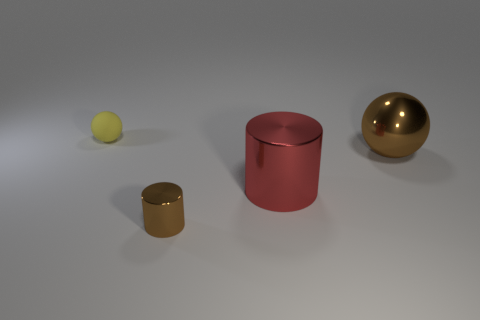What is the shape of the small brown thing?
Your response must be concise. Cylinder. How many other objects are the same material as the tiny brown cylinder?
Keep it short and to the point. 2. Do the red shiny cylinder and the brown sphere have the same size?
Your answer should be very brief. Yes. There is a object left of the brown shiny cylinder; what shape is it?
Your answer should be very brief. Sphere. What is the color of the small thing that is to the right of the ball that is on the left side of the small brown metallic thing?
Give a very brief answer. Brown. Do the metal object in front of the large red thing and the large object in front of the brown metallic ball have the same shape?
Give a very brief answer. Yes. There is a shiny thing that is the same size as the red metallic cylinder; what is its shape?
Ensure brevity in your answer.  Sphere. What color is the big thing that is the same material as the large brown ball?
Offer a very short reply. Red. Does the small brown shiny object have the same shape as the big shiny object that is in front of the brown ball?
Provide a short and direct response. Yes. There is a object that is the same size as the brown metallic cylinder; what is its material?
Keep it short and to the point. Rubber. 